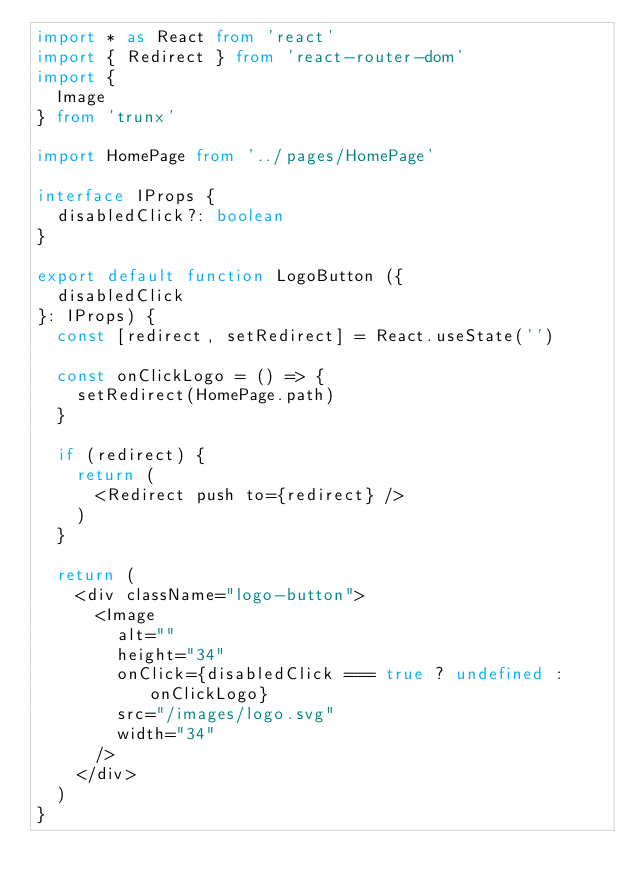Convert code to text. <code><loc_0><loc_0><loc_500><loc_500><_TypeScript_>import * as React from 'react'
import { Redirect } from 'react-router-dom'
import {
  Image
} from 'trunx'

import HomePage from '../pages/HomePage'

interface IProps {
  disabledClick?: boolean
}

export default function LogoButton ({
  disabledClick
}: IProps) {
  const [redirect, setRedirect] = React.useState('')

  const onClickLogo = () => {
    setRedirect(HomePage.path)
  }

  if (redirect) {
    return (
      <Redirect push to={redirect} />
    )
  }

  return (
    <div className="logo-button">
      <Image
        alt=""
        height="34"
        onClick={disabledClick === true ? undefined : onClickLogo}
        src="/images/logo.svg"
        width="34"
      />
    </div>
  )
}
</code> 